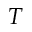<formula> <loc_0><loc_0><loc_500><loc_500>T</formula> 